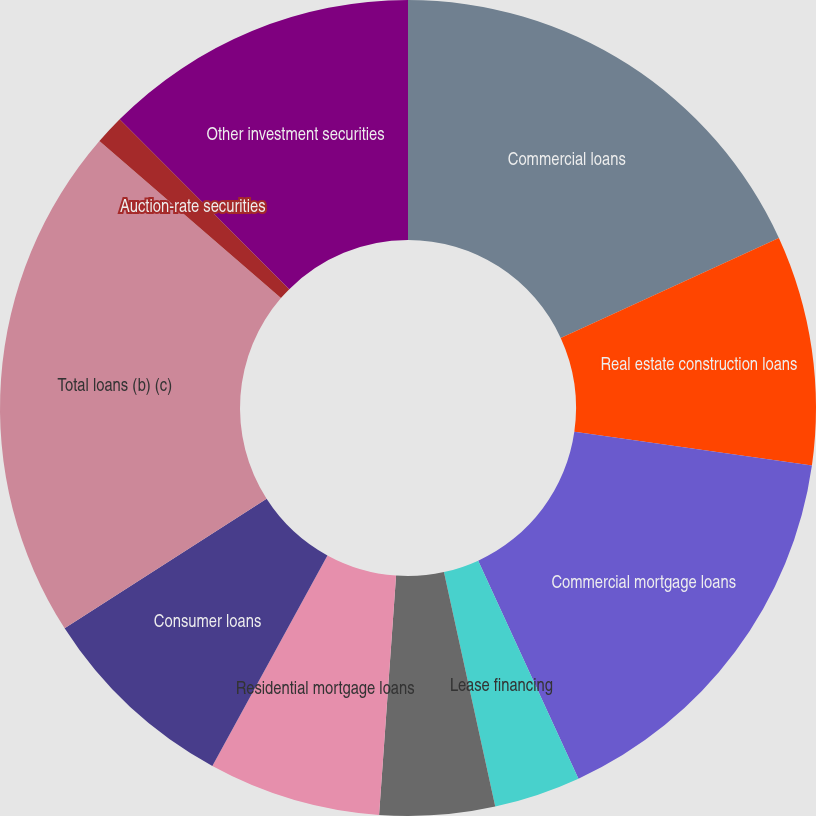Convert chart. <chart><loc_0><loc_0><loc_500><loc_500><pie_chart><fcel>Commercial loans<fcel>Real estate construction loans<fcel>Commercial mortgage loans<fcel>Lease financing<fcel>International loans<fcel>Residential mortgage loans<fcel>Consumer loans<fcel>Total loans (b) (c)<fcel>Auction-rate securities<fcel>Other investment securities<nl><fcel>18.16%<fcel>9.09%<fcel>15.89%<fcel>3.43%<fcel>4.56%<fcel>6.83%<fcel>7.96%<fcel>20.43%<fcel>1.16%<fcel>12.49%<nl></chart> 